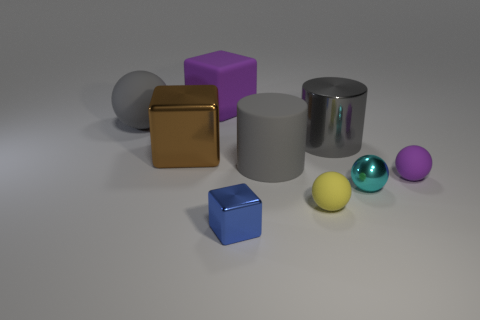Subtract all gray cubes. Subtract all blue spheres. How many cubes are left? 3 Add 1 gray matte balls. How many objects exist? 10 Subtract all cylinders. How many objects are left? 7 Add 5 big brown metallic things. How many big brown metallic things exist? 6 Subtract 0 green cubes. How many objects are left? 9 Subtract all big gray rubber cylinders. Subtract all tiny rubber objects. How many objects are left? 6 Add 2 yellow rubber things. How many yellow rubber things are left? 3 